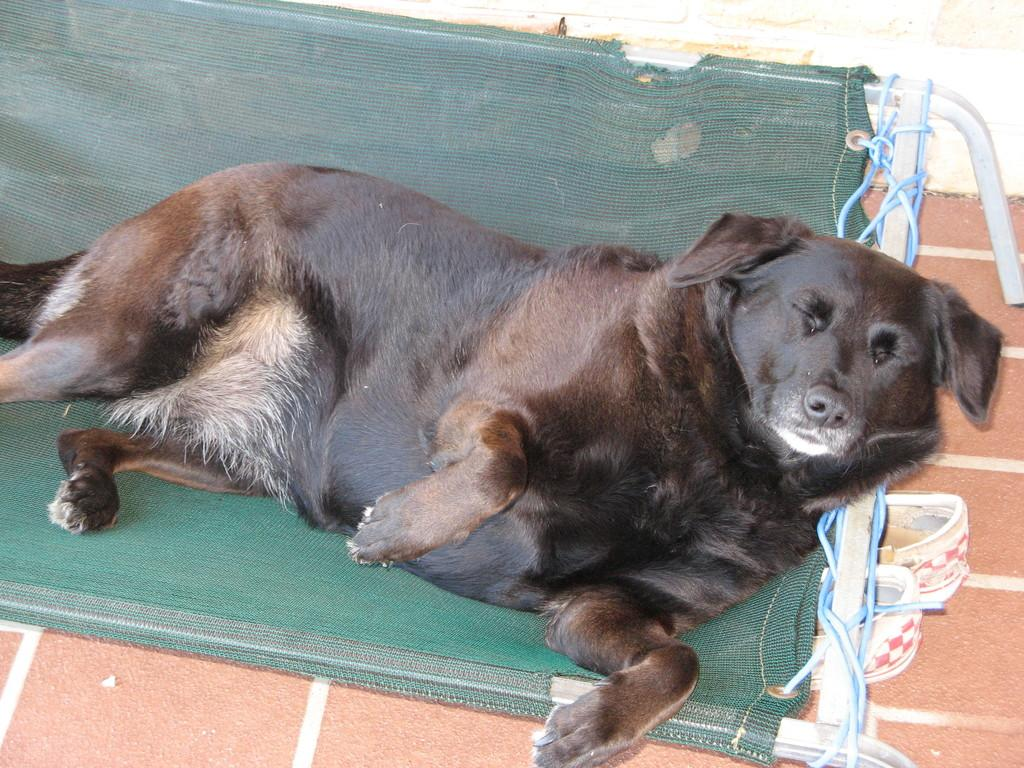What type of animal is in the image? There is a black dog in the image. What is the dog doing in the image? The dog is lying on a green bed. What else can be seen under the bed? There is a pair of shoes under the bed. What color is the carpet in the image? There is an orange carpet in the image. How many cherries are on the dog's tail in the image? There are no cherries present in the image, and the dog's tail is not visible. Can you describe the land where the dog is located in the image? The image does not show any specific land or location; it only shows a dog lying on a green bed. 